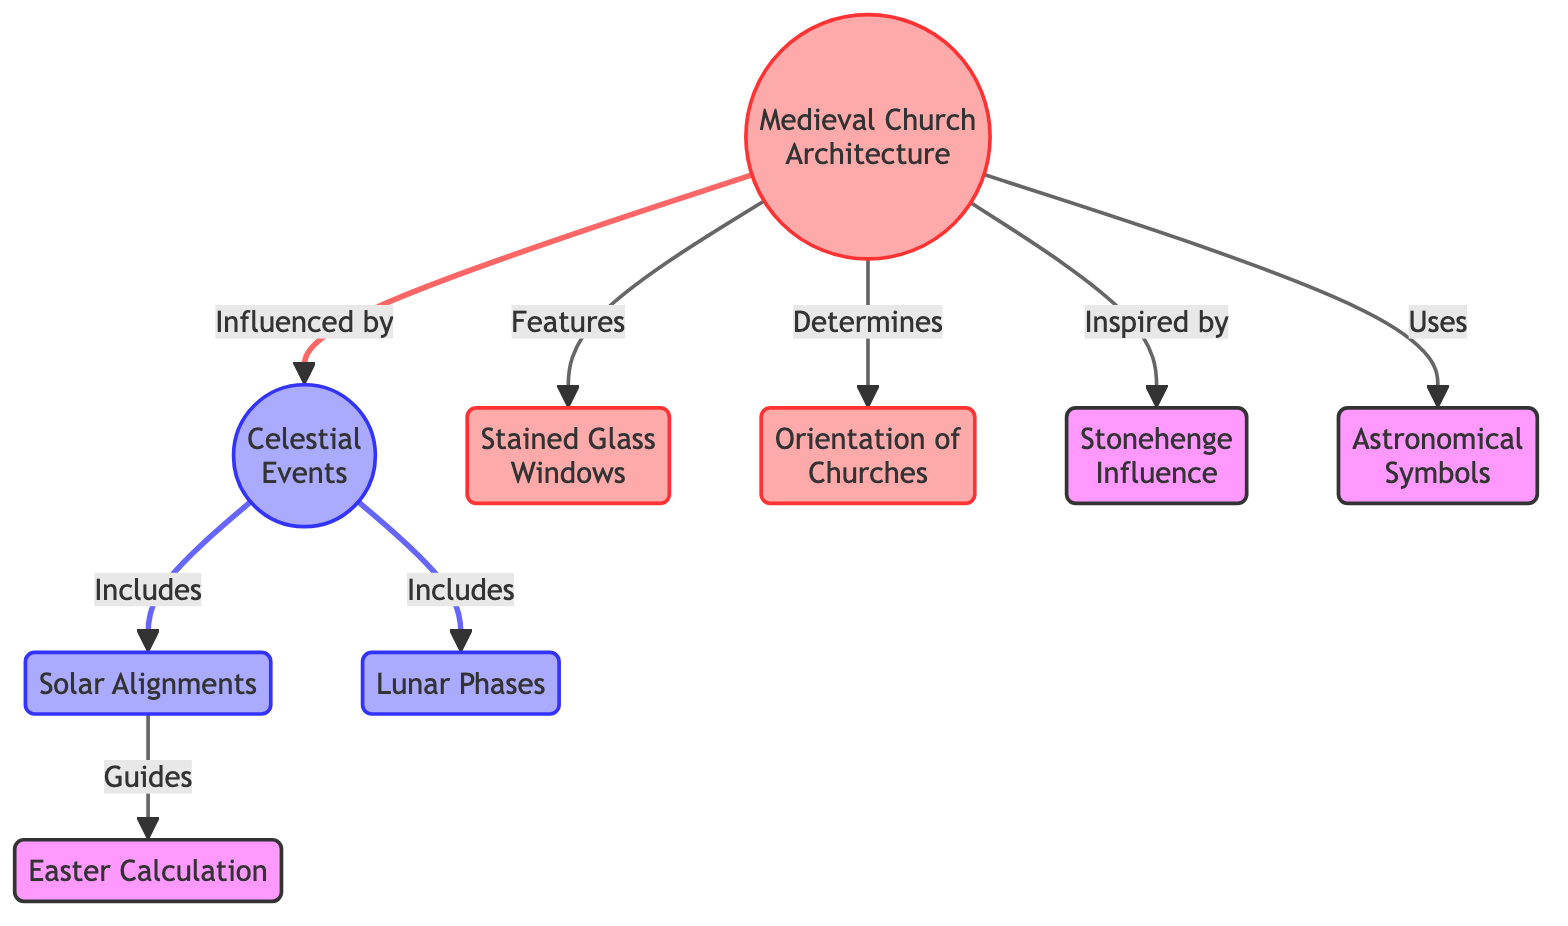What is the main subject of the diagram? The diagram's title indicates that it focuses on the relationship between celestial events and medieval church architecture, suggesting that the main subject is how celestial events influenced the design and structure of churches during the medieval period.
Answer: Medieval Church Architecture How many celestial events are included in the diagram? The diagram lists two specific celestial events: Solar Alignments and Lunar Phases, which are indicated as part of the "Celestial Events" node. Therefore, the total count of celestial events is two.
Answer: 2 Which architectural feature is influenced by celestial events? The diagram shows that "Stained Glass Windows" is a feature that is directly linked to medieval church architecture, indicating its influence from celestial events.
Answer: Stained Glass Windows What guides the calculation of Easter? The diagram indicates that "Solar Alignments" are the celestial event that guides the calculation of Easter, as shown in the link connected to the Easter Calculation node.
Answer: Solar Alignments Which event inspired the orientation of churches? The diagram connects the node "Orientation of Churches" directly to the main subject "Medieval Church Architecture," depicting that celestial events had a significant impact on determining the orientation of churches, though it does not specify a single event. This indicates that multiple celestial factors contributed to this architectural aspect.
Answer: Celestial Events What is the relationship between Stonehenge and medieval church architecture? The diagram shows that "Stonehenge Influence" is mentioned as something that inspired medieval church architecture, which suggests a historical and cultural connection between these two elements.
Answer: Inspired by How many features are directly determined by celestial events in the diagram? The diagram connects celestial events to three features of medieval church architecture: Stained Glass Windows, Orientation of Churches, and the use of Astronomical Symbols. Thus, these three features are directly determined by celestial events.
Answer: 3 What type of symbols are used in medieval churches according to the diagram? The diagram specifies that "Astronomical Symbols" are a type of element utilized in the design and decoration of medieval churches, indicating a clear relationship with celestial events.
Answer: Astronomical Symbols Which node is connected to both Solar Alignments and Easter Calculation? The diagram links "Solar Alignments" directly to "Easter Calculation," indicating that both nodes share this celestial event as a common influence.
Answer: Solar Alignments 